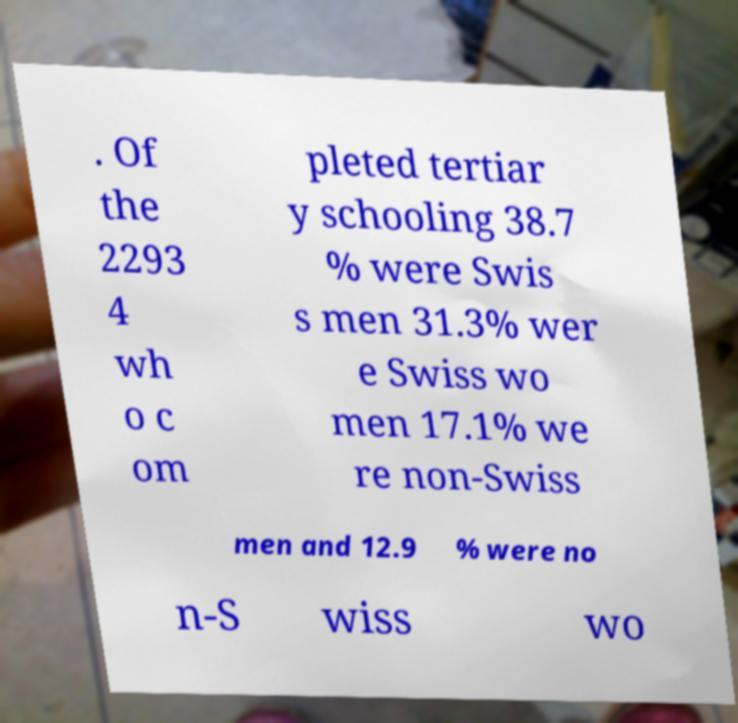There's text embedded in this image that I need extracted. Can you transcribe it verbatim? . Of the 2293 4 wh o c om pleted tertiar y schooling 38.7 % were Swis s men 31.3% wer e Swiss wo men 17.1% we re non-Swiss men and 12.9 % were no n-S wiss wo 